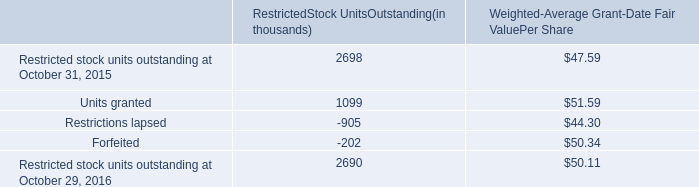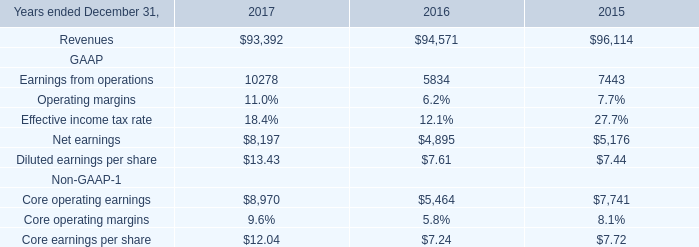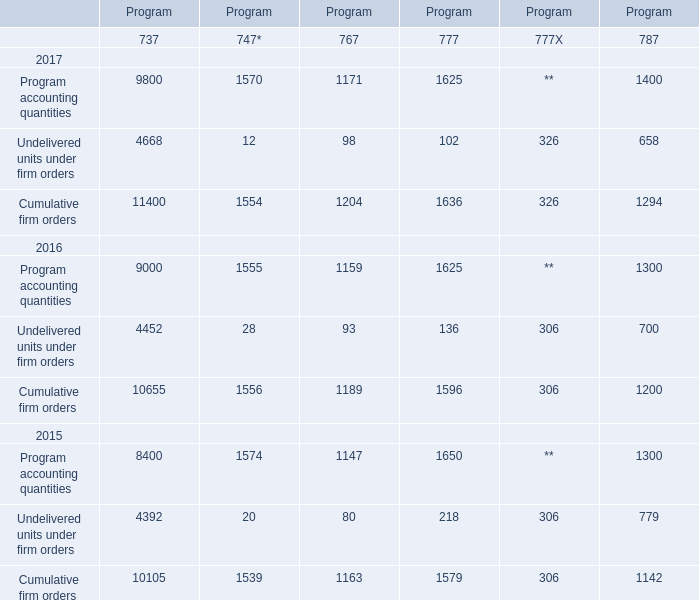What is the sum of Cumulative firm orders 2017 of Program.5, Net earnings GAAP of 2016, and Cumulative firm orders 2016 of Program.2 ? 
Computations: ((1294.0 + 4895.0) + 1189.0)
Answer: 7378.0. 